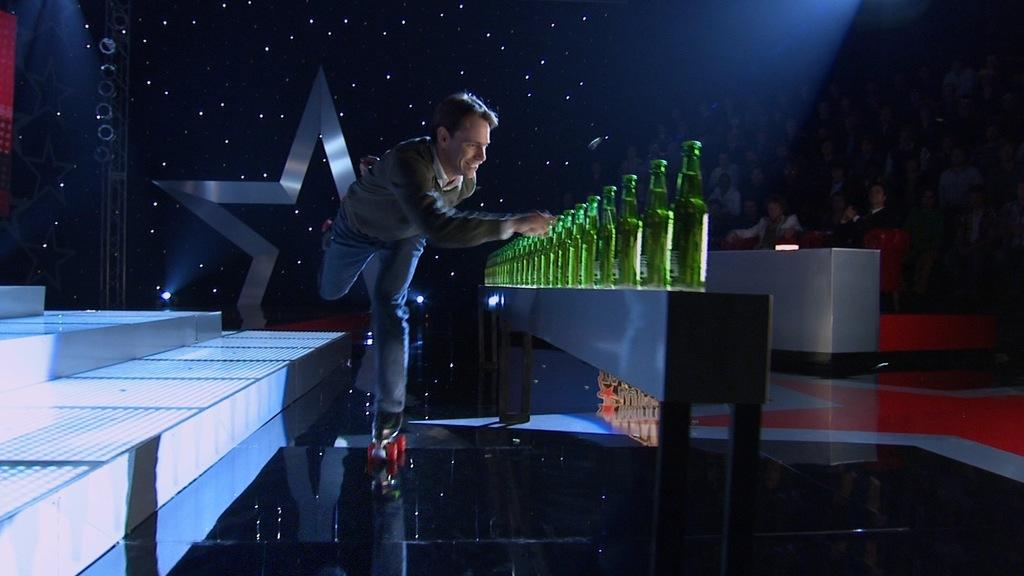What is the main subject of the image? The main subject of the image is a man. What is the man doing in the image? The man is roller skating and opening a series of bottles. What type of wave can be seen crashing on the shore in the image? There is no wave or shore present in the image; it features a man roller skating and opening bottles. 